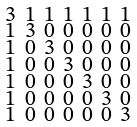Convert formula to latex. <formula><loc_0><loc_0><loc_500><loc_500>\begin{smallmatrix} 3 & 1 & 1 & 1 & 1 & 1 & 1 \\ 1 & 3 & 0 & 0 & 0 & 0 & 0 \\ 1 & 0 & 3 & 0 & 0 & 0 & 0 \\ 1 & 0 & 0 & 3 & 0 & 0 & 0 \\ 1 & 0 & 0 & 0 & 3 & 0 & 0 \\ 1 & 0 & 0 & 0 & 0 & 3 & 0 \\ 1 & 0 & 0 & 0 & 0 & 0 & 3 \end{smallmatrix}</formula> 